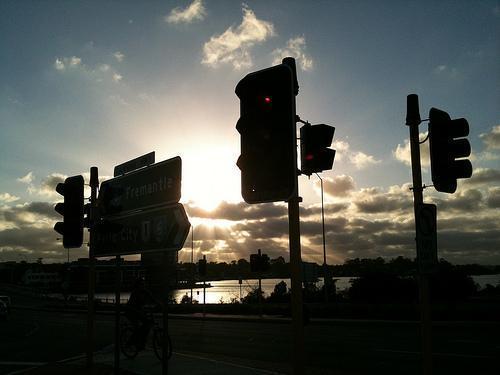How many dinosaurs are in the picture?
Give a very brief answer. 0. How many stoplights are in the picture?
Give a very brief answer. 3. 